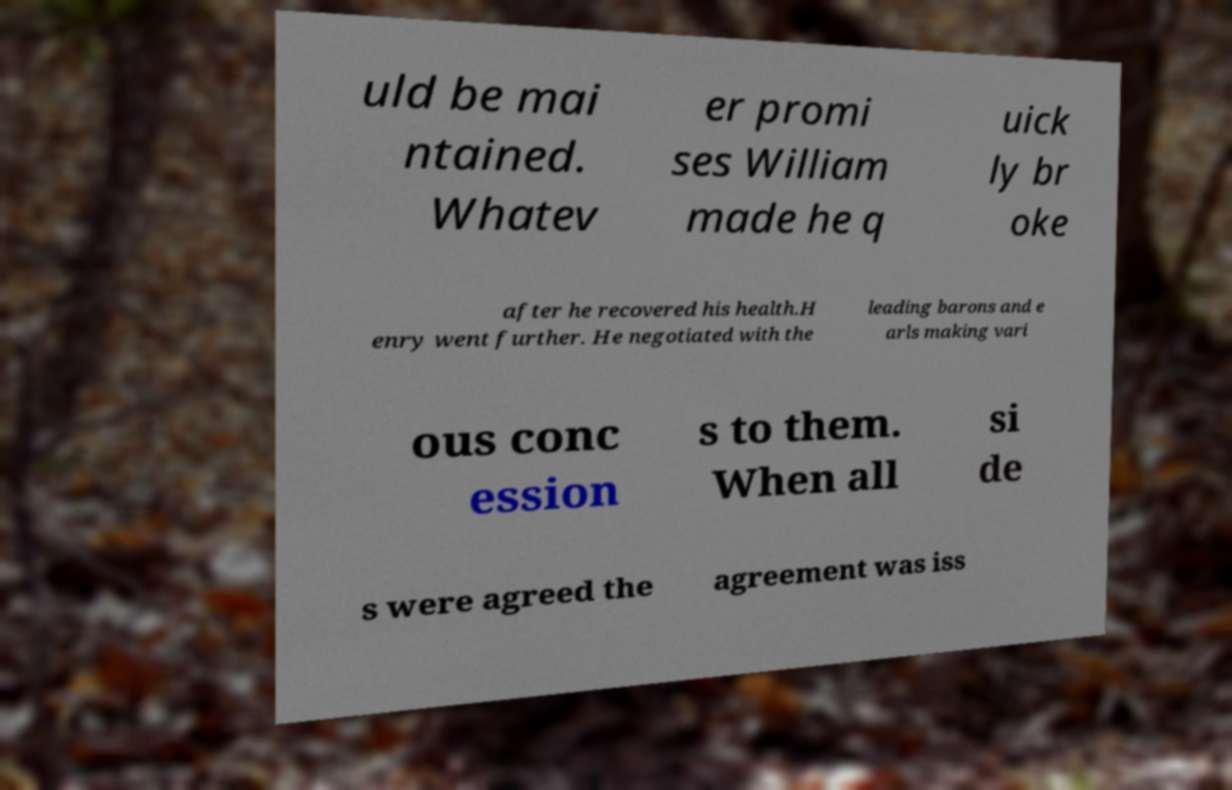Can you read and provide the text displayed in the image?This photo seems to have some interesting text. Can you extract and type it out for me? uld be mai ntained. Whatev er promi ses William made he q uick ly br oke after he recovered his health.H enry went further. He negotiated with the leading barons and e arls making vari ous conc ession s to them. When all si de s were agreed the agreement was iss 